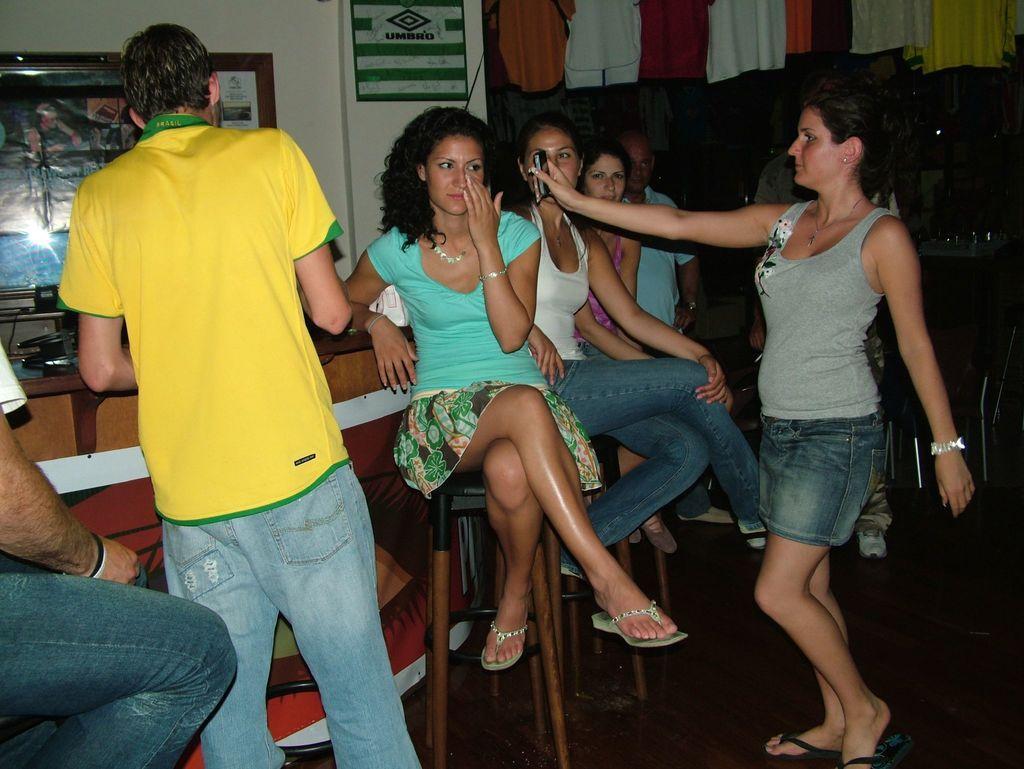Please provide a concise description of this image. In this picture we can see the group of girl sitting on a chair and looking to the mobile, holding by the woman, who is standing in the front. Behind we can see the table and white wall with hanging photo frame. 